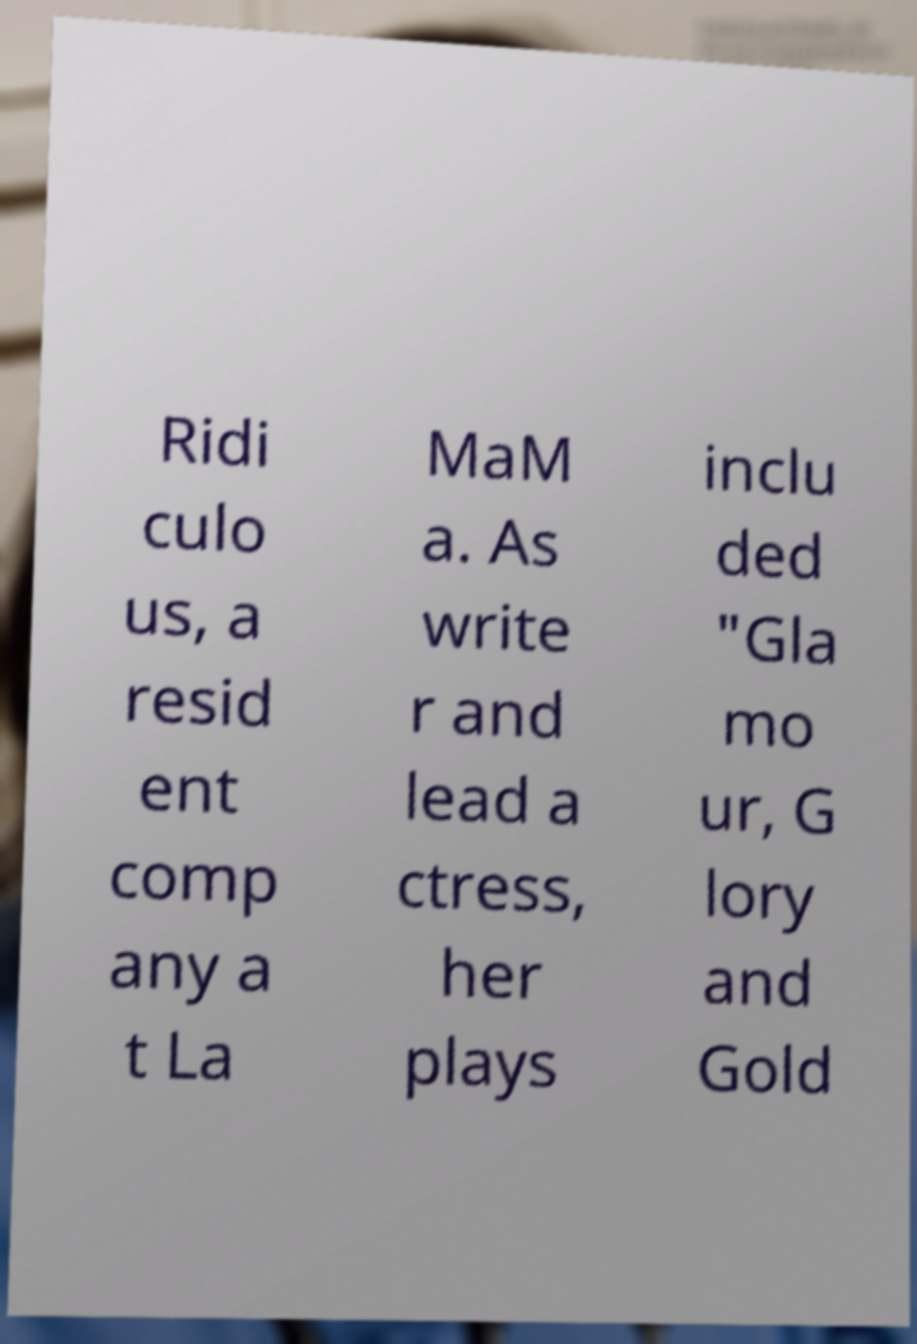Could you extract and type out the text from this image? Ridi culo us, a resid ent comp any a t La MaM a. As write r and lead a ctress, her plays inclu ded "Gla mo ur, G lory and Gold 